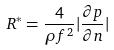<formula> <loc_0><loc_0><loc_500><loc_500>R ^ { * } = \frac { 4 } { \rho f ^ { 2 } } | \frac { \partial p } { \partial n } |</formula> 